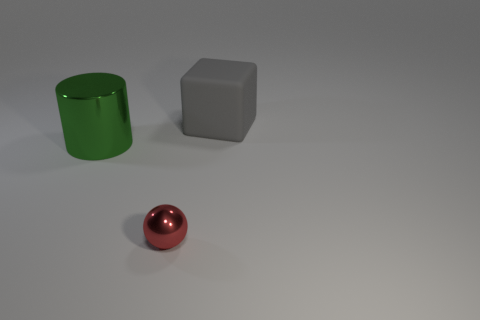Add 3 large brown cubes. How many objects exist? 6 Subtract all spheres. How many objects are left? 2 Add 3 large gray blocks. How many large gray blocks are left? 4 Add 2 large gray metallic balls. How many large gray metallic balls exist? 2 Subtract 0 cyan cylinders. How many objects are left? 3 Subtract all tiny gray shiny cylinders. Subtract all large green metal objects. How many objects are left? 2 